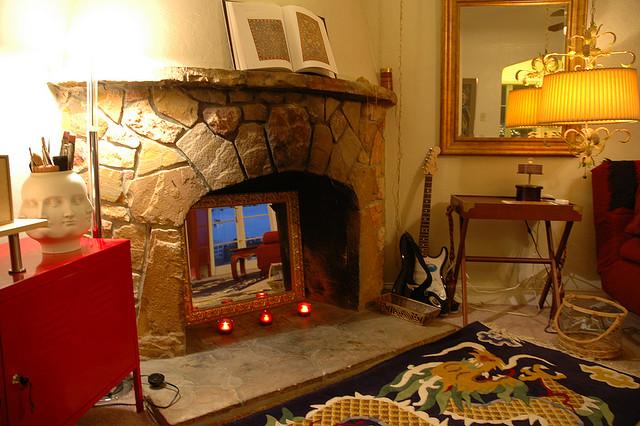Is there an instrument leaning on the wall?
Answer briefly. Yes. What is in front of the mirror?
Short answer required. Lamp. Is there a fireplace?
Concise answer only. Yes. 